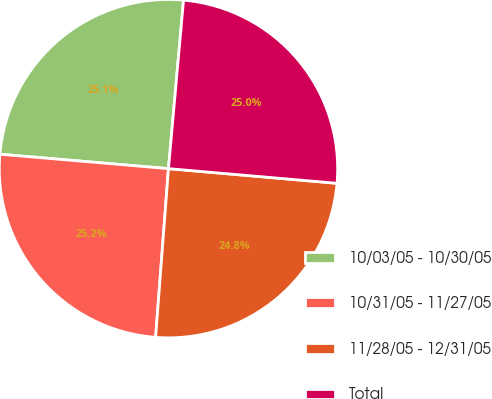Convert chart. <chart><loc_0><loc_0><loc_500><loc_500><pie_chart><fcel>10/03/05 - 10/30/05<fcel>10/31/05 - 11/27/05<fcel>11/28/05 - 12/31/05<fcel>Total<nl><fcel>25.06%<fcel>25.15%<fcel>24.83%<fcel>24.96%<nl></chart> 